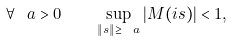Convert formula to latex. <formula><loc_0><loc_0><loc_500><loc_500>\forall \ a > 0 \quad \sup _ { \| s \| \geq \ a } \left | M ( i s ) \right | < 1 ,</formula> 